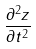<formula> <loc_0><loc_0><loc_500><loc_500>\frac { \partial ^ { 2 } z } { \partial t ^ { 2 } }</formula> 